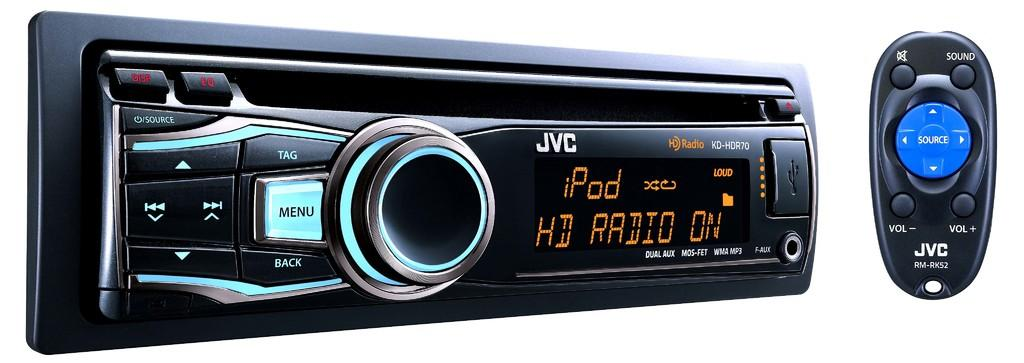<image>
Give a short and clear explanation of the subsequent image. A radio receiver for a car with the model number KD-HDR70. 